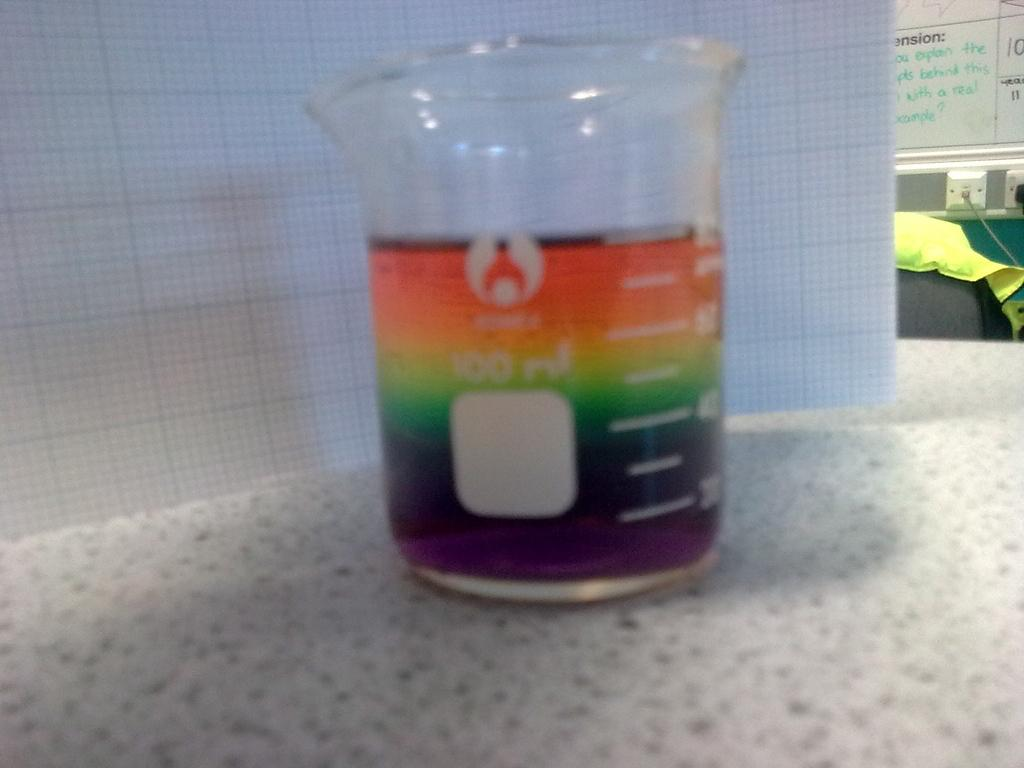<image>
Write a terse but informative summary of the picture. A beaker that can measure up to 100 milliliters has a rainbow solution in it. 